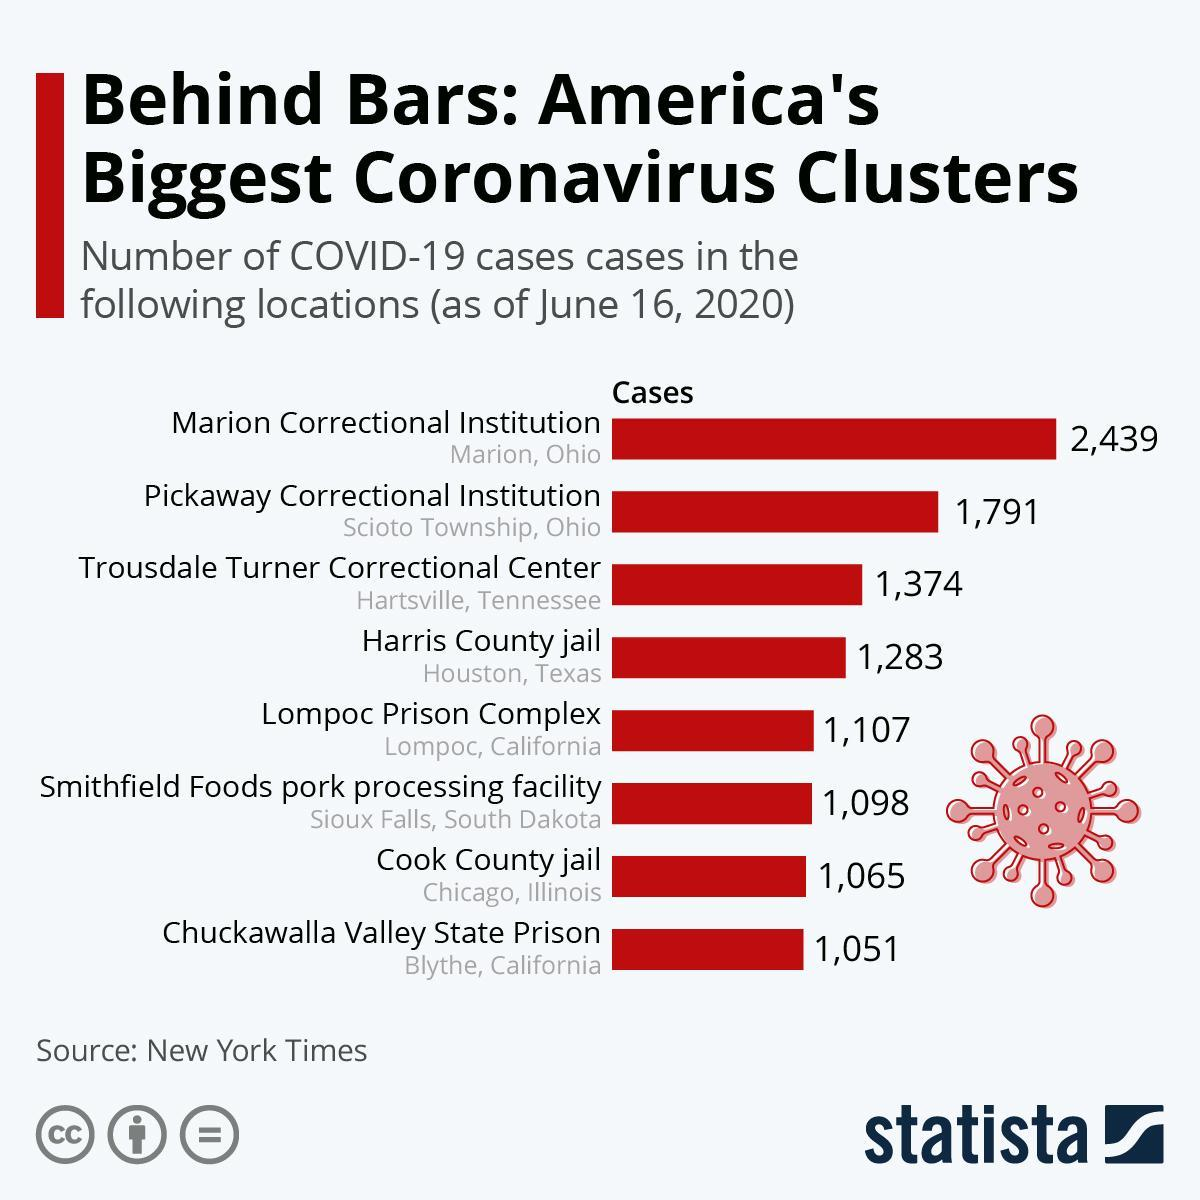What is the number of COVID-19 cases in Cook County Jail in Chicago as of June 16, 2020?
Answer the question with a short phrase. 1,065 How many Covid-19 cases were reported in Harris County jail in Houston, Texas as of June 16, 2020? 1,283 